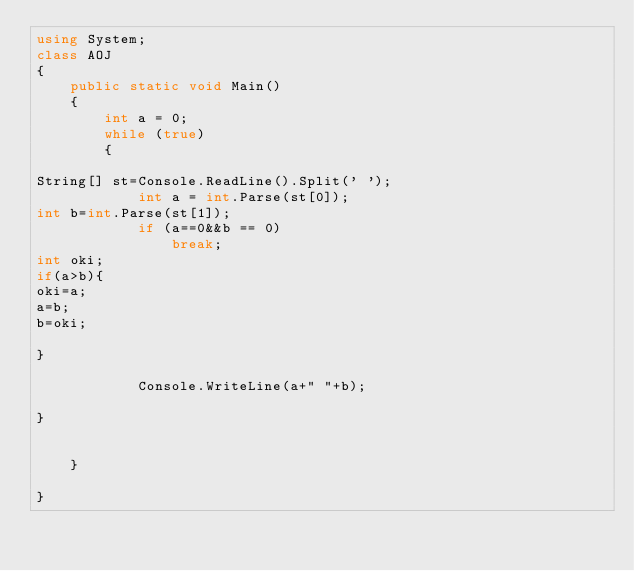Convert code to text. <code><loc_0><loc_0><loc_500><loc_500><_C#_>using System;
class AOJ
{
    public static void Main()
    {
        int a = 0;
        while (true)
        {
          
String[] st=Console.ReadLine().Split(' ');
            int a = int.Parse(st[0]);
int b=int.Parse(st[1]);
            if (a==0&&b == 0)
                break;
int oki;
if(a>b){
oki=a;
a=b;
b=oki;

}

            Console.WriteLine(a+" "+b);
        
}


    }

}</code> 